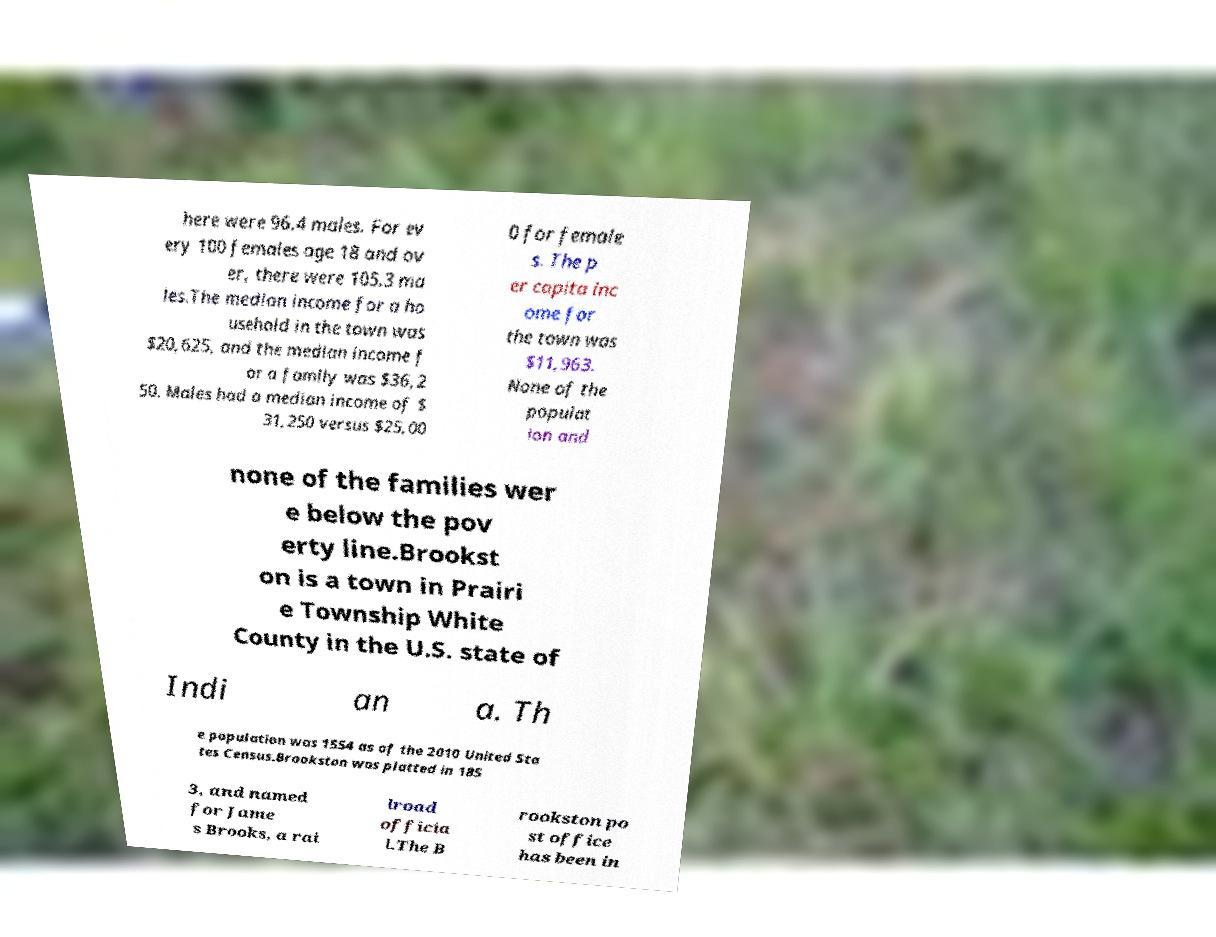What messages or text are displayed in this image? I need them in a readable, typed format. here were 96.4 males. For ev ery 100 females age 18 and ov er, there were 105.3 ma les.The median income for a ho usehold in the town was $20,625, and the median income f or a family was $36,2 50. Males had a median income of $ 31,250 versus $25,00 0 for female s. The p er capita inc ome for the town was $11,963. None of the populat ion and none of the families wer e below the pov erty line.Brookst on is a town in Prairi e Township White County in the U.S. state of Indi an a. Th e population was 1554 as of the 2010 United Sta tes Census.Brookston was platted in 185 3, and named for Jame s Brooks, a rai lroad officia l.The B rookston po st office has been in 